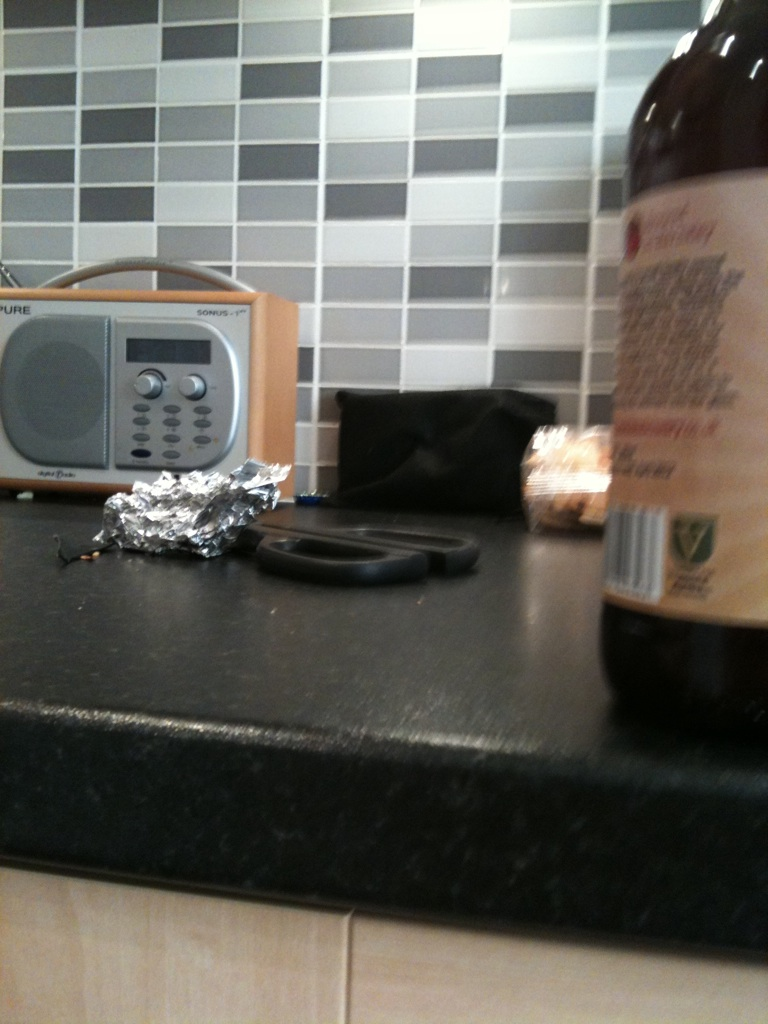What are the objects visible in the image aside from the bottle? Aside from the bottle, the image shows a modern kitchen setting with items like a radio, scissors, aluminum foil, a loaf of bread, a black bag or purse, and a granite countertop. 